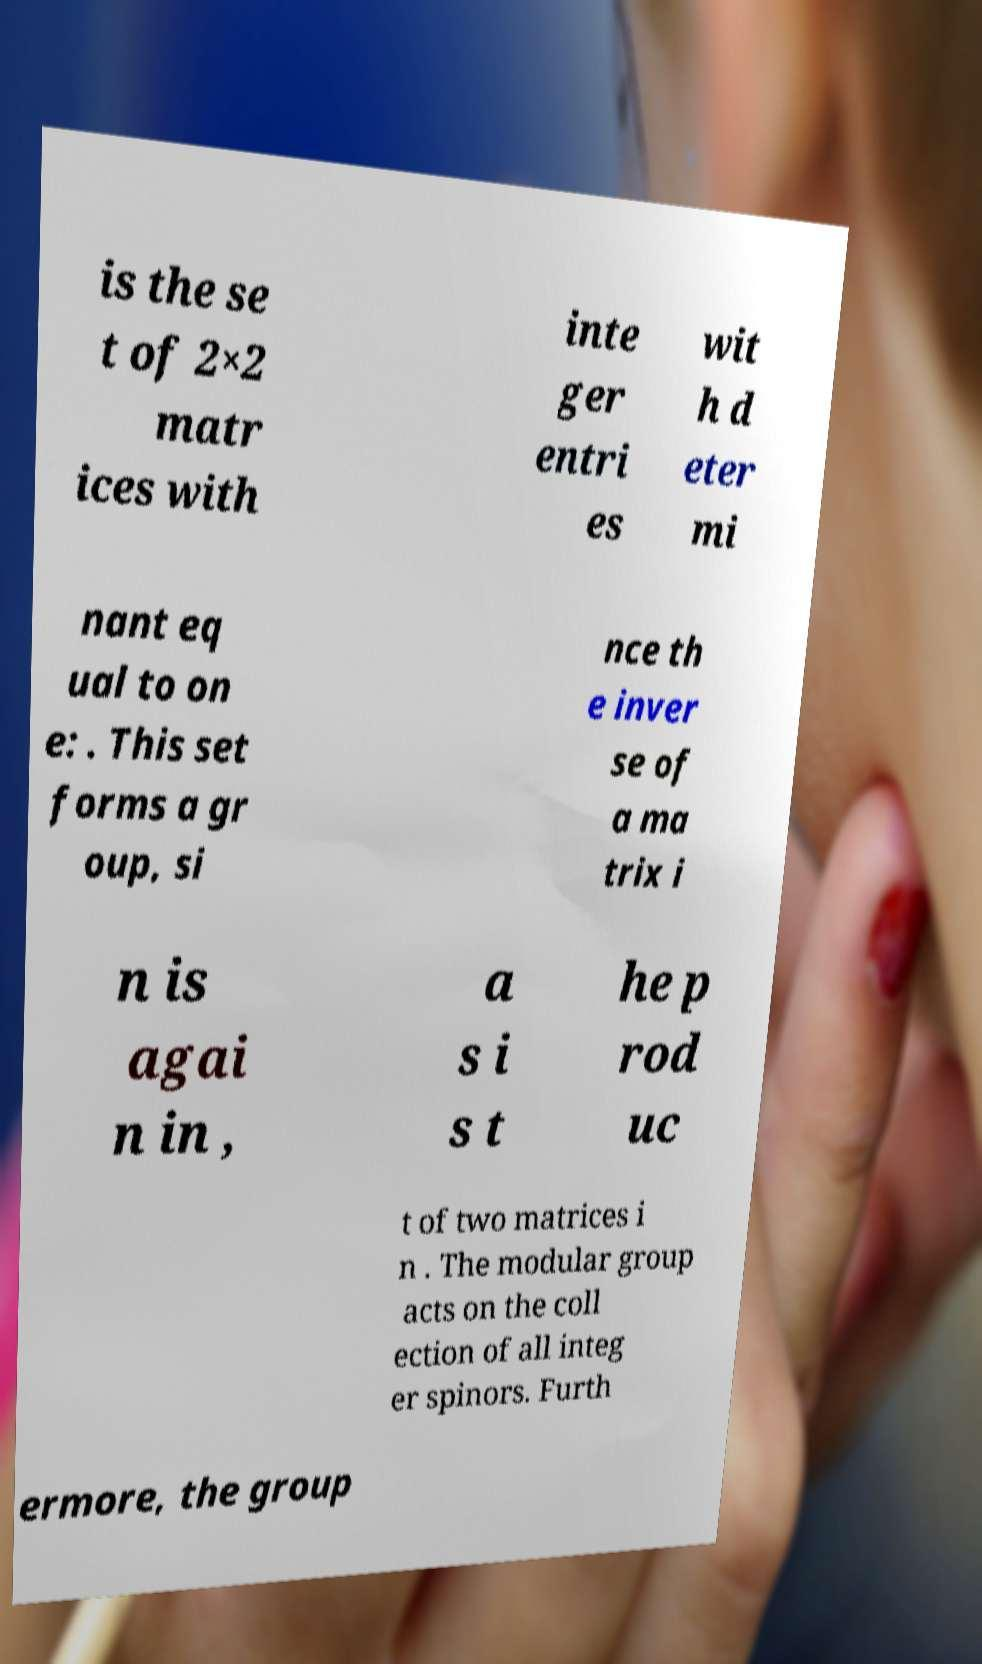For documentation purposes, I need the text within this image transcribed. Could you provide that? is the se t of 2×2 matr ices with inte ger entri es wit h d eter mi nant eq ual to on e: . This set forms a gr oup, si nce th e inver se of a ma trix i n is agai n in , a s i s t he p rod uc t of two matrices i n . The modular group acts on the coll ection of all integ er spinors. Furth ermore, the group 